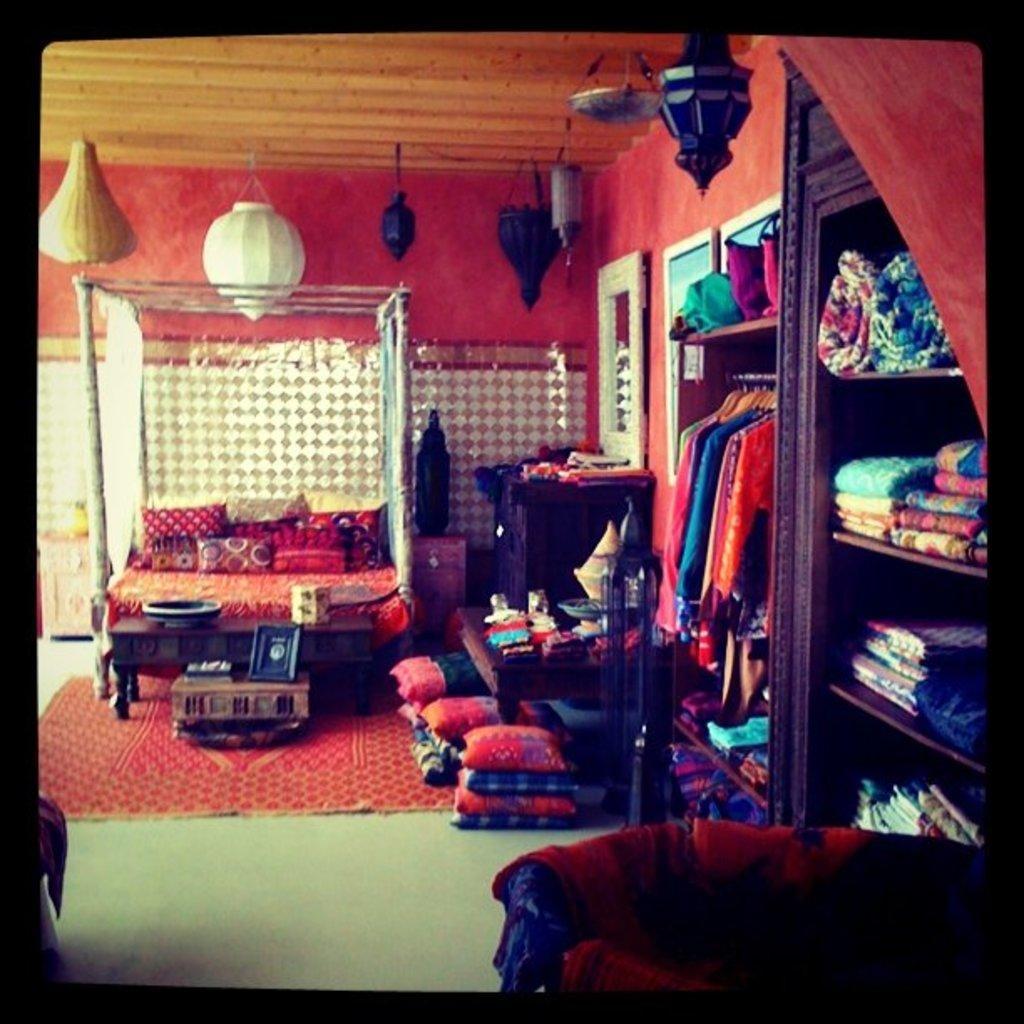Could you give a brief overview of what you see in this image? This is a picture of a room, in this picture on the right side there are cupboards, in the cupboards there are some clothes. And in the center there is couch, on the couch there are pillows and beside the couch there are some pillows, tables. And on the table there are some clothes, and there is another table. On the table there are some objects, and in the background there is wall at the bottom there is floor. And on the floor there is carpet and in the bottom right hand corner there are some pillows are visible, and at the top of the image there are some lamps and ceiling. 